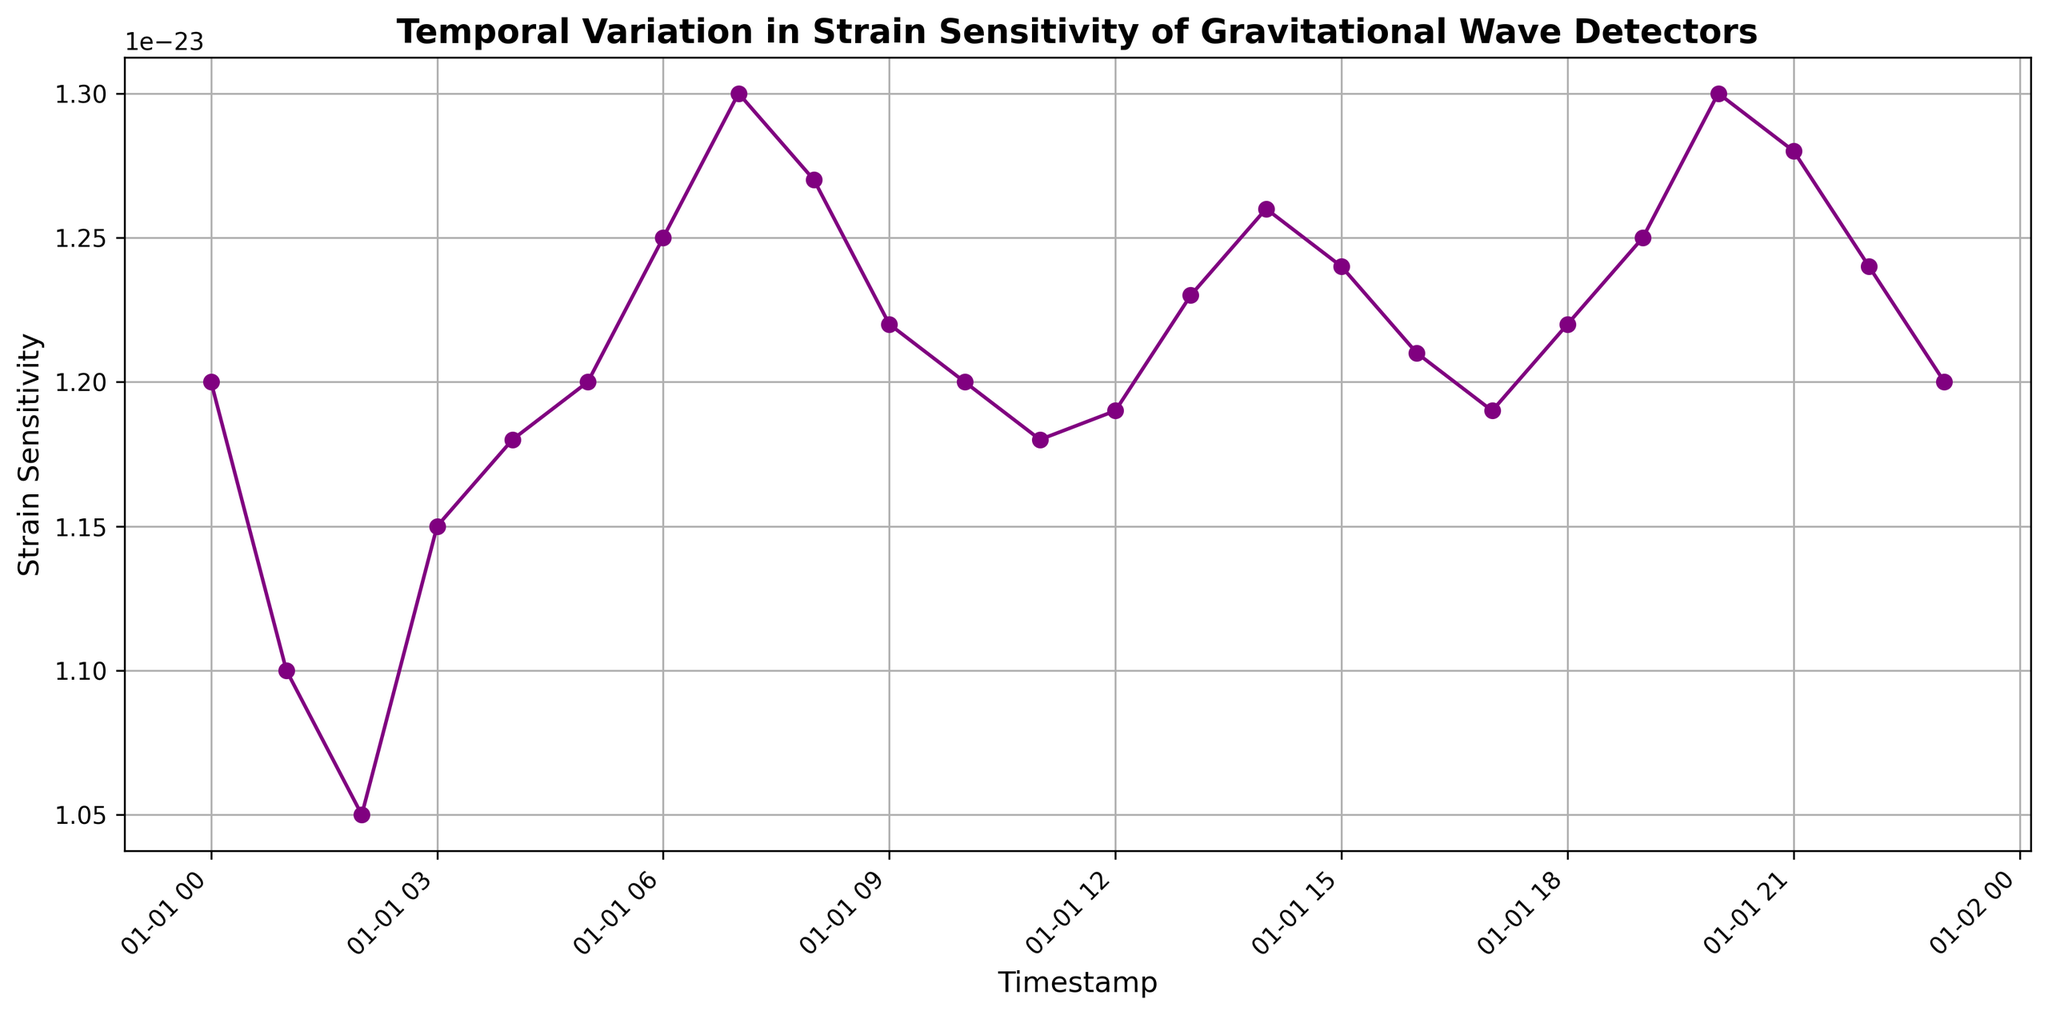What is the initial strain sensitivity recorded? The initial strain sensitivity is the first value on the y-axis corresponding to the timestamp 2023-01-01T00:00:00Z. The figure shows this value as 1.2e-23.
Answer: 1.2e-23 At what timestamp does the maximum strain sensitivity occur? To find the maximum, locate the highest point on the y-axis and trace it to the x-axis. The highest strain sensitivity of 1.3e-23 occurs at timestamp 2023-01-01T07:00:00Z.
Answer: 2023-01-01T07:00:00Z How does the strain sensitivity trend between 2023-01-01T00:00:00Z and 2023-01-01T06:00:00Z? Observing the plot from the initial timestamp to 2023-01-01T06:00:00Z, the strain sensitivity first decreases then fluctuates slightly before increasing.
Answer: Decrease then Increase What is the average strain sensitivity over the first 12 hours? To calculate the average, sum the strain sensitivities from the first 12 data points and divide by 12. The values are: 1.2e-23, 1.1e-23, 1.05e-23, 1.15e-23, 1.18e-23, 1.2e-23, 1.25e-23, 1.3e-23, 1.27e-23, 1.22e-23, 1.2e-23, 1.18e-23. Their sum is 13.3e-23, and the average is 13.3e-23 / 12 ≈ 1.108e-23.
Answer: 1.108e-23 Between which timestamps does the strain sensitivity show the steepest increase? The steepest increase can be found by locating the segment where the slope is the steepest. The steepest rise occurs between 2023-01-01T06:00:00Z (1.25e-23) and 2023-01-01T07:00:00Z (1.3e-23), an increase of 0.05e-23 within 1 hour.
Answer: 2023-01-01T06:00:00Z to 2023-01-01T07:00:00Z How many times does the strain sensitivity reach 1.2e-23? By identifying every instance of 1.2e-23 on the y-axis, it happens at timestamps 2023-01-01T00:00:00Z, 2023-01-01T05:00:00Z, 2023-01-01T10:00:00Z, and 2023-01-01T23:00:00Z, totaling 4 times.
Answer: 4 Is there any noticeable pattern in the strain sensitivity towards the end of the day? Observing the latter part of the plot, from 2023-01-01T18:00:00Z to 2023-01-01T23:00:00Z, the strain sensitivity fluctuates slightly but shows an overall stable behavior with minor variations.
Answer: Stable with minor fluctuations Which hour marks the first instance of a decrease in strain sensitivity after showing an increase? Starting from the first timestamp, the first instance where an increase is followed by a decrease is between 2023-01-01T02:00:00Z (1.05e-23) and 2023-01-01T03:00:00Z (1.15e-23), and then a decrease to 1.18e-23 at 2023-01-01T04:00:00Z.
Answer: 2023-01-01T03:00:00Z What is the median value of strain sensitivity across the entire day? To find the median, list all strain sensitivity values and find the middle point. The sorted values are: 1.05e-23, 1.1e-23, 1.15e-23, 1.18e-23, 1.18e-23, 1.19e-23, 1.19e-23, 1.2e-23, 1.2e-23, 1.2e-23, 1.22e-23, 1.22e-23, 1.23e-23, 1.24e-23, 1.24e-23, 1.25e-23, 1.25e-23, 1.26e-23, 1.27e-23, 1.3e-23. The middle values are 1.2e-23 and 1.22e-23, so the median is (1.2e-23 + 1.22e-23) / 2 = 1.21e-23.
Answer: 1.21e-23 